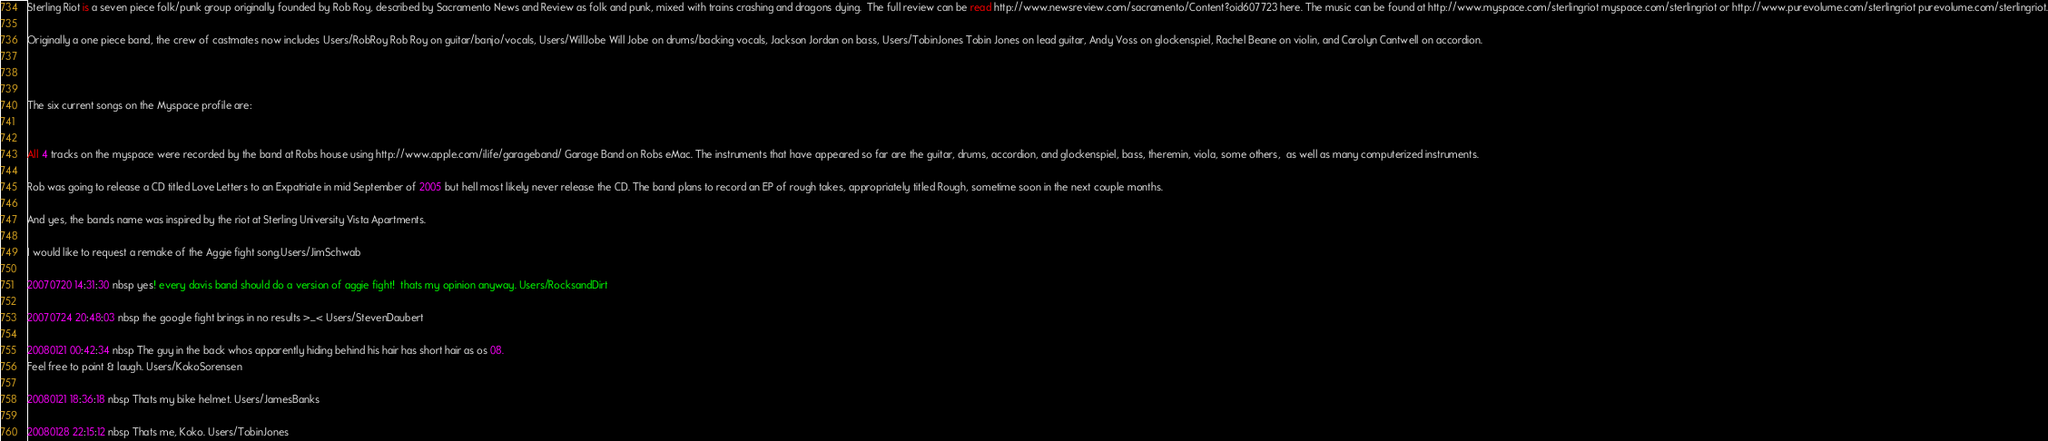<code> <loc_0><loc_0><loc_500><loc_500><_FORTRAN_>
Sterling Riot is a seven piece folk/punk group originally founded by Rob Roy, described by Sacramento News and Review as folk and punk, mixed with trains crashing and dragons dying.  The full review can be read http://www.newsreview.com/sacramento/Content?oid607723 here. The music can be found at http://www.myspace.com/sterlingriot myspace.com/sterlingriot or http://www.purevolume.com/sterlingriot purevolume.com/sterlingriot.

Originally a one piece band, the crew of castmates now includes Users/RobRoy Rob Roy on guitar/banjo/vocals, Users/WillJobe Will Jobe on drums/backing vocals, Jackson Jordan on bass, Users/TobinJones Tobin Jones on lead guitar, Andy Voss on glockenspiel, Rachel Beane on violin, and Carolyn Cantwell on accordion.



The six current songs on the Myspace profile are:


All 4 tracks on the myspace were recorded by the band at Robs house using http://www.apple.com/ilife/garageband/ Garage Band on Robs eMac. The instruments that have appeared so far are the guitar, drums, accordion, and glockenspiel, bass, theremin, viola, some others,  as well as many computerized instruments.

Rob was going to release a CD titled Love Letters to an Expatriate in mid September of 2005 but hell most likely never release the CD. The band plans to record an EP of rough takes, appropriately titled Rough, sometime soon in the next couple months.

And yes, the bands name was inspired by the riot at Sterling University Vista Apartments.

I would like to request a remake of the Aggie fight song.Users/JimSchwab

20070720 14:31:30 nbsp yes! every davis band should do a version of aggie fight!  thats my opinion anyway. Users/RocksandDirt

20070724 20:48:03 nbsp the google fight brings in no results >_< Users/StevenDaubert

20080121 00:42:34 nbsp The guy in the back whos apparently hiding behind his hair has short hair as os 08.
Feel free to point & laugh. Users/KokoSorensen

20080121 18:36:18 nbsp Thats my bike helmet. Users/JamesBanks

20080128 22:15:12 nbsp Thats me, Koko. Users/TobinJones
</code> 